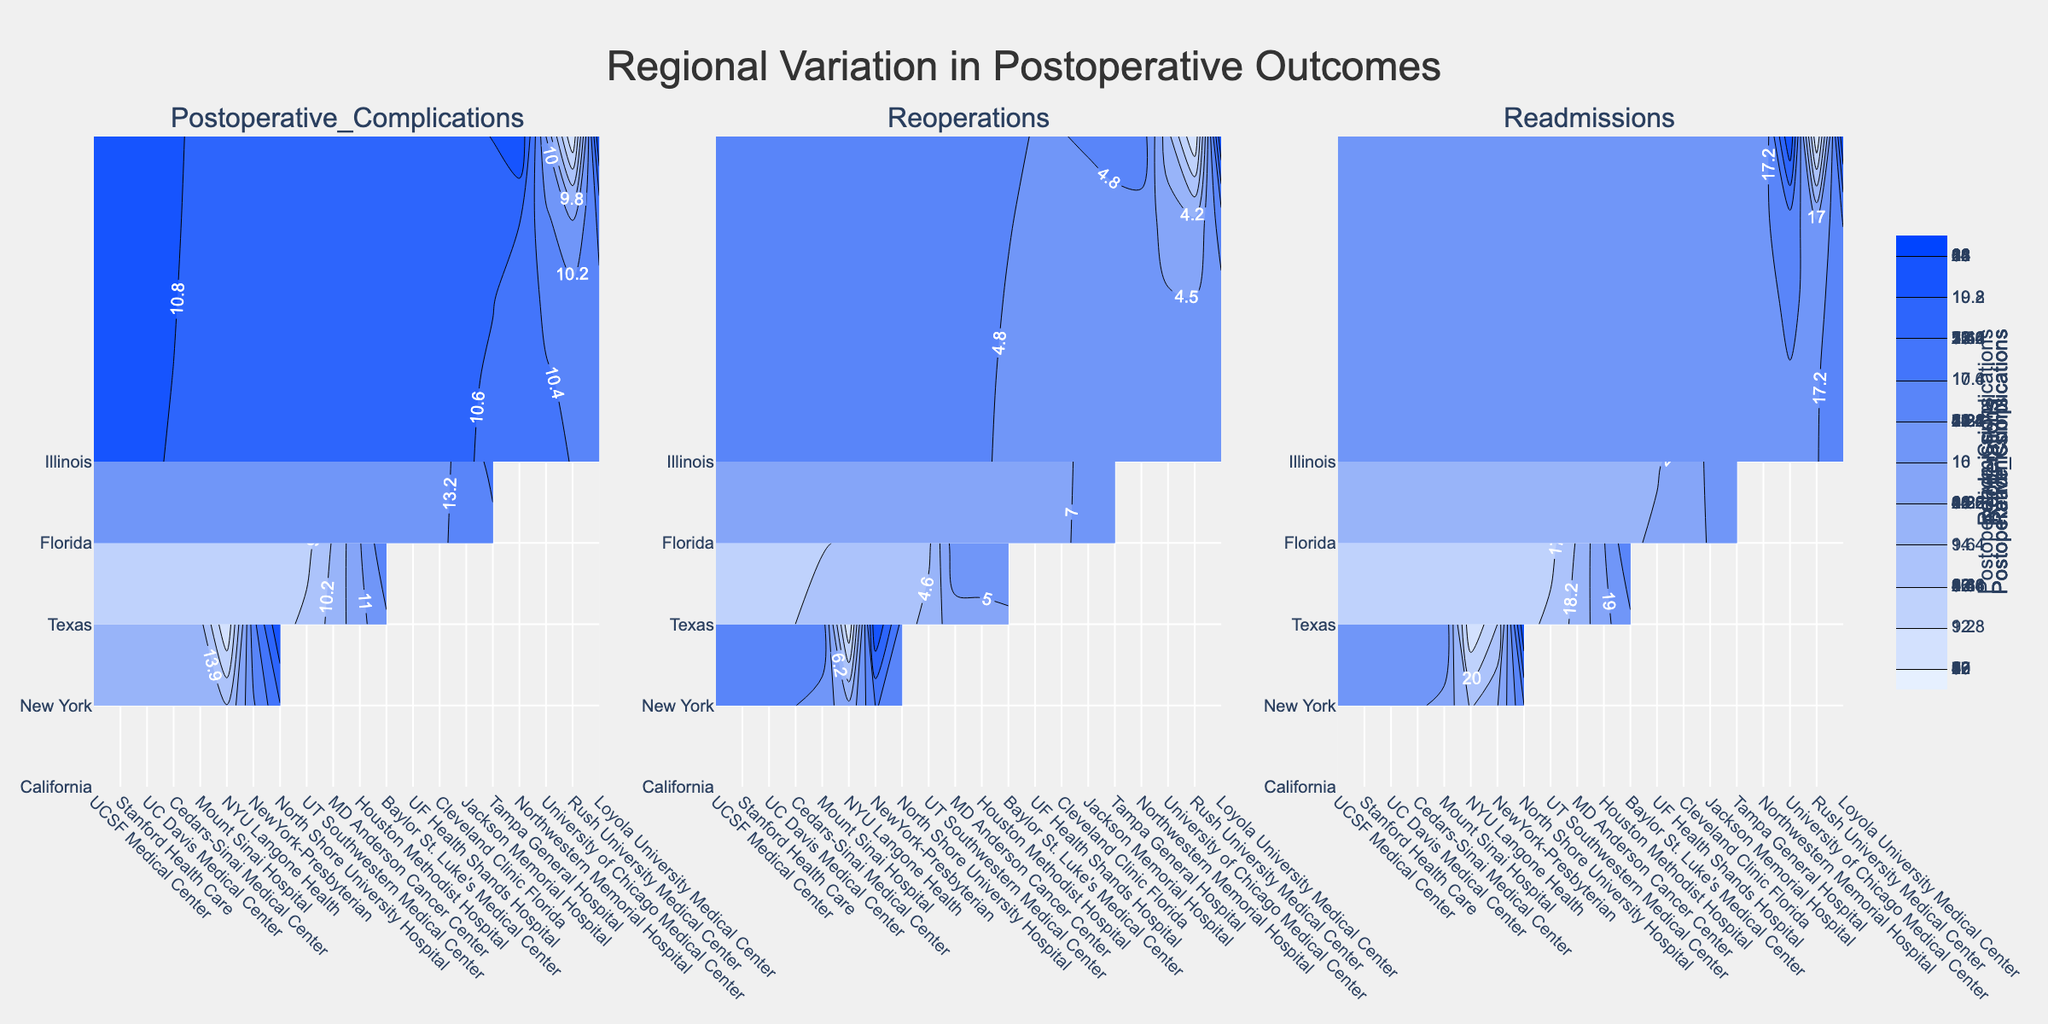what is the title of the figure? The title is typically positioned at the top of the figure. It serves as an overview of what the figure represents.
Answer: Regional Variation in Postoperative Outcomes Which state has the highest postoperative complications in the list? Examine the contour plot for the 'Postoperative Complications' subplot. Look for the state with the highest value under that metric.
Answer: New York How many different states are shown in the contour plots? By observing the y-axis labels across the subplots, count the unique states that appear.
Answer: Four Among the three metrics, which one has the highest range of values for Florida? For Florida, identify the maximum and minimum values in each of the three subplots and calculate the difference for the range. Compare the ranges to determine the highest.
Answer: Readmissions Is the rate of reoperations generally higher in Texas or Illinois? Observe the contour plot for reoperations. Compare the overall color intensities and the specific values for Texas and Illinois.
Answer: Illinois Which hospital has the fewest postoperative complications in California? In the 'Postoperative Complications' subplot, find the hospital in California with the lowest value.
Answer: Cedars-Sinai Medical Center Are readmissions consistently higher in Florida compared to Texas? Compare the intensity and values of the 'Readmissions' subplot for hospitals in Florida vs. Texas.
Answer: Yes What is the average postoperative complications rate at hospitals in Illinois? For Illinois hospitals, take note of the values in the 'Postoperative Complications' subplot, sum them up and divide by the number of hospitals in Illinois.
Answer: 10 Which state has the most variation in reoperations? By looking at the contour plot for reoperations, observe the spread and range of values for each state. Identify the state with the largest range.
Answer: Florida 